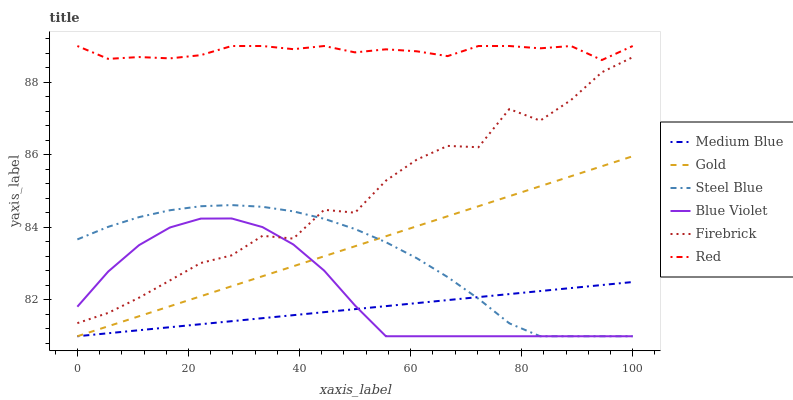Does Medium Blue have the minimum area under the curve?
Answer yes or no. Yes. Does Red have the maximum area under the curve?
Answer yes or no. Yes. Does Firebrick have the minimum area under the curve?
Answer yes or no. No. Does Firebrick have the maximum area under the curve?
Answer yes or no. No. Is Gold the smoothest?
Answer yes or no. Yes. Is Firebrick the roughest?
Answer yes or no. Yes. Is Medium Blue the smoothest?
Answer yes or no. No. Is Medium Blue the roughest?
Answer yes or no. No. Does Gold have the lowest value?
Answer yes or no. Yes. Does Firebrick have the lowest value?
Answer yes or no. No. Does Red have the highest value?
Answer yes or no. Yes. Does Firebrick have the highest value?
Answer yes or no. No. Is Firebrick less than Red?
Answer yes or no. Yes. Is Red greater than Gold?
Answer yes or no. Yes. Does Blue Violet intersect Steel Blue?
Answer yes or no. Yes. Is Blue Violet less than Steel Blue?
Answer yes or no. No. Is Blue Violet greater than Steel Blue?
Answer yes or no. No. Does Firebrick intersect Red?
Answer yes or no. No. 